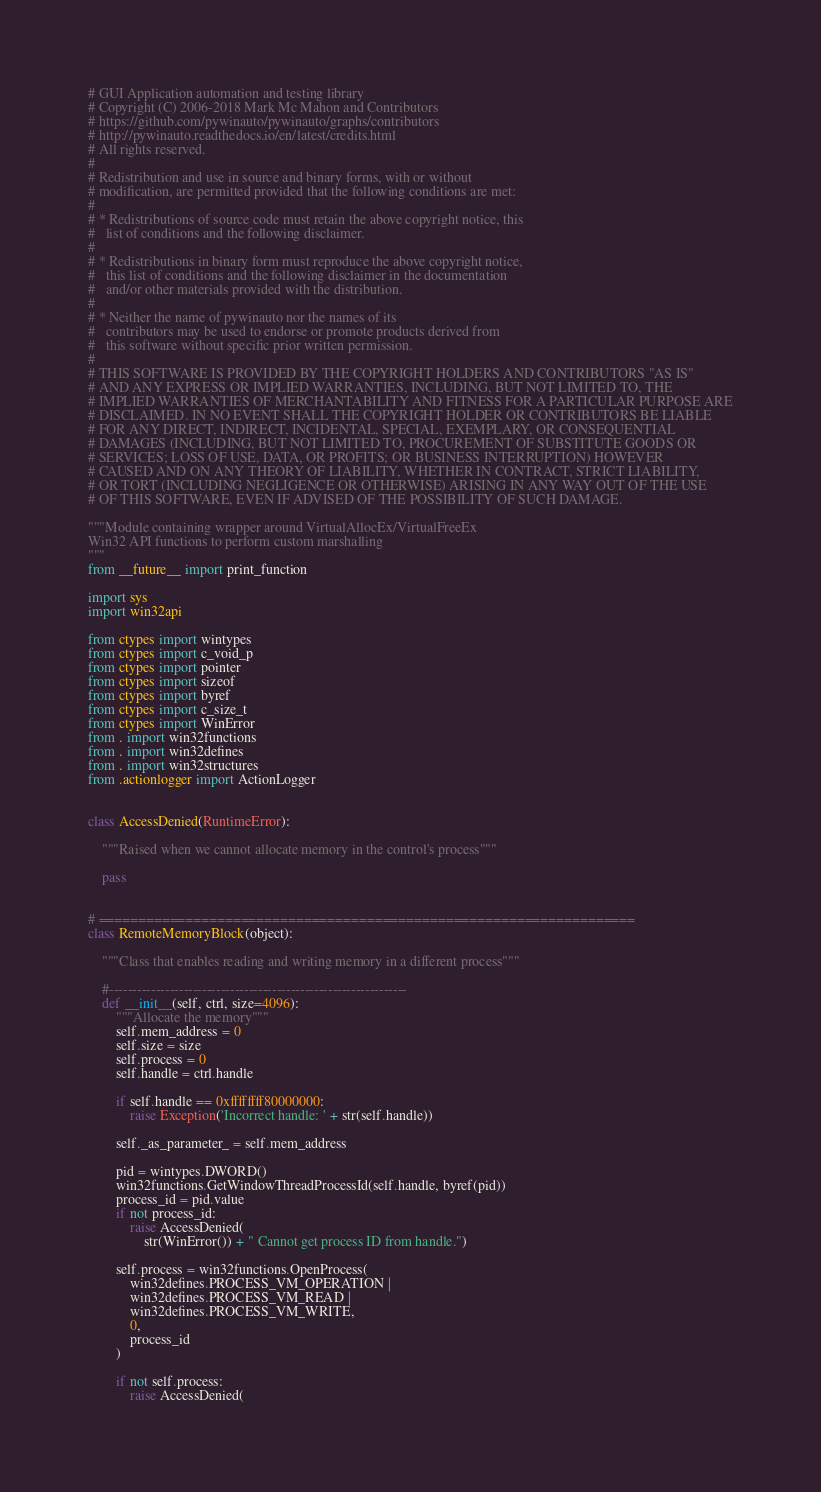<code> <loc_0><loc_0><loc_500><loc_500><_Python_># GUI Application automation and testing library
# Copyright (C) 2006-2018 Mark Mc Mahon and Contributors
# https://github.com/pywinauto/pywinauto/graphs/contributors
# http://pywinauto.readthedocs.io/en/latest/credits.html
# All rights reserved.
#
# Redistribution and use in source and binary forms, with or without
# modification, are permitted provided that the following conditions are met:
#
# * Redistributions of source code must retain the above copyright notice, this
#   list of conditions and the following disclaimer.
#
# * Redistributions in binary form must reproduce the above copyright notice,
#   this list of conditions and the following disclaimer in the documentation
#   and/or other materials provided with the distribution.
#
# * Neither the name of pywinauto nor the names of its
#   contributors may be used to endorse or promote products derived from
#   this software without specific prior written permission.
#
# THIS SOFTWARE IS PROVIDED BY THE COPYRIGHT HOLDERS AND CONTRIBUTORS "AS IS"
# AND ANY EXPRESS OR IMPLIED WARRANTIES, INCLUDING, BUT NOT LIMITED TO, THE
# IMPLIED WARRANTIES OF MERCHANTABILITY AND FITNESS FOR A PARTICULAR PURPOSE ARE
# DISCLAIMED. IN NO EVENT SHALL THE COPYRIGHT HOLDER OR CONTRIBUTORS BE LIABLE
# FOR ANY DIRECT, INDIRECT, INCIDENTAL, SPECIAL, EXEMPLARY, OR CONSEQUENTIAL
# DAMAGES (INCLUDING, BUT NOT LIMITED TO, PROCUREMENT OF SUBSTITUTE GOODS OR
# SERVICES; LOSS OF USE, DATA, OR PROFITS; OR BUSINESS INTERRUPTION) HOWEVER
# CAUSED AND ON ANY THEORY OF LIABILITY, WHETHER IN CONTRACT, STRICT LIABILITY,
# OR TORT (INCLUDING NEGLIGENCE OR OTHERWISE) ARISING IN ANY WAY OUT OF THE USE
# OF THIS SOFTWARE, EVEN IF ADVISED OF THE POSSIBILITY OF SUCH DAMAGE.

"""Module containing wrapper around VirtualAllocEx/VirtualFreeEx
Win32 API functions to perform custom marshalling
"""
from __future__ import print_function

import sys
import win32api

from ctypes import wintypes
from ctypes import c_void_p
from ctypes import pointer
from ctypes import sizeof
from ctypes import byref
from ctypes import c_size_t
from ctypes import WinError
from . import win32functions
from . import win32defines
from . import win32structures
from .actionlogger import ActionLogger


class AccessDenied(RuntimeError):

    """Raised when we cannot allocate memory in the control's process"""

    pass


# ====================================================================
class RemoteMemoryBlock(object):

    """Class that enables reading and writing memory in a different process"""

    #----------------------------------------------------------------
    def __init__(self, ctrl, size=4096):
        """Allocate the memory"""
        self.mem_address = 0
        self.size = size
        self.process = 0
        self.handle = ctrl.handle

        if self.handle == 0xffffffff80000000:
            raise Exception('Incorrect handle: ' + str(self.handle))

        self._as_parameter_ = self.mem_address

        pid = wintypes.DWORD()
        win32functions.GetWindowThreadProcessId(self.handle, byref(pid))
        process_id = pid.value
        if not process_id:
            raise AccessDenied(
                str(WinError()) + " Cannot get process ID from handle.")

        self.process = win32functions.OpenProcess(
            win32defines.PROCESS_VM_OPERATION |
            win32defines.PROCESS_VM_READ |
            win32defines.PROCESS_VM_WRITE,
            0,
            process_id
        )

        if not self.process:
            raise AccessDenied(</code> 